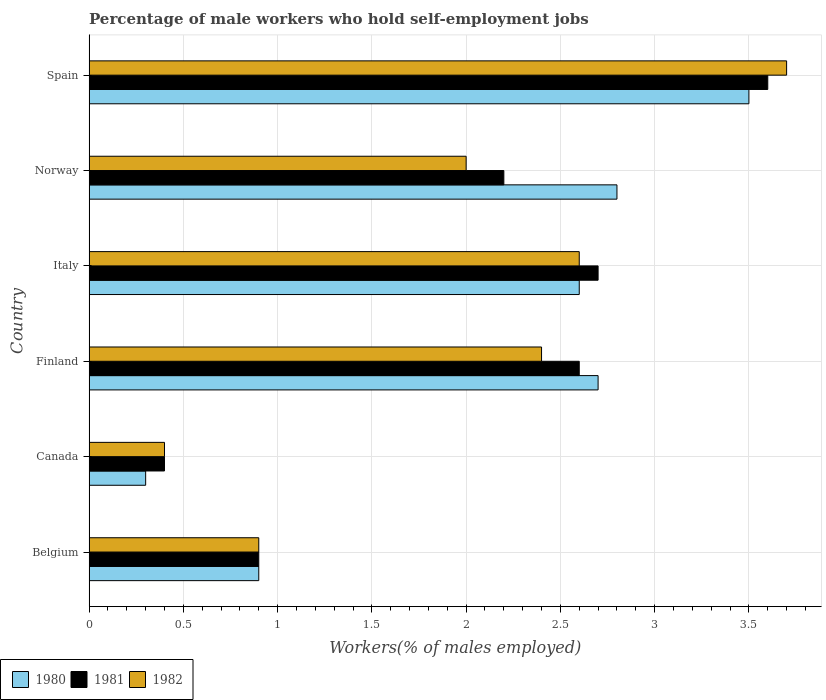How many groups of bars are there?
Offer a terse response. 6. Are the number of bars per tick equal to the number of legend labels?
Give a very brief answer. Yes. Are the number of bars on each tick of the Y-axis equal?
Ensure brevity in your answer.  Yes. How many bars are there on the 4th tick from the top?
Your answer should be compact. 3. How many bars are there on the 5th tick from the bottom?
Offer a very short reply. 3. What is the label of the 5th group of bars from the top?
Offer a very short reply. Canada. In how many cases, is the number of bars for a given country not equal to the number of legend labels?
Give a very brief answer. 0. What is the percentage of self-employed male workers in 1981 in Norway?
Your answer should be compact. 2.2. Across all countries, what is the maximum percentage of self-employed male workers in 1982?
Provide a short and direct response. 3.7. Across all countries, what is the minimum percentage of self-employed male workers in 1981?
Give a very brief answer. 0.4. What is the total percentage of self-employed male workers in 1982 in the graph?
Offer a terse response. 12. What is the difference between the percentage of self-employed male workers in 1982 in Italy and the percentage of self-employed male workers in 1980 in Norway?
Your answer should be compact. -0.2. What is the average percentage of self-employed male workers in 1980 per country?
Ensure brevity in your answer.  2.13. What is the difference between the percentage of self-employed male workers in 1980 and percentage of self-employed male workers in 1982 in Norway?
Make the answer very short. 0.8. In how many countries, is the percentage of self-employed male workers in 1982 greater than 0.30000000000000004 %?
Ensure brevity in your answer.  6. What is the ratio of the percentage of self-employed male workers in 1981 in Finland to that in Spain?
Your response must be concise. 0.72. What is the difference between the highest and the second highest percentage of self-employed male workers in 1980?
Your answer should be compact. 0.7. What is the difference between the highest and the lowest percentage of self-employed male workers in 1981?
Ensure brevity in your answer.  3.2. In how many countries, is the percentage of self-employed male workers in 1982 greater than the average percentage of self-employed male workers in 1982 taken over all countries?
Your answer should be very brief. 3. Is the sum of the percentage of self-employed male workers in 1981 in Canada and Finland greater than the maximum percentage of self-employed male workers in 1980 across all countries?
Provide a succinct answer. No. What does the 3rd bar from the top in Spain represents?
Offer a very short reply. 1980. Is it the case that in every country, the sum of the percentage of self-employed male workers in 1980 and percentage of self-employed male workers in 1982 is greater than the percentage of self-employed male workers in 1981?
Provide a short and direct response. Yes. How many bars are there?
Offer a terse response. 18. Are all the bars in the graph horizontal?
Keep it short and to the point. Yes. How many countries are there in the graph?
Give a very brief answer. 6. What is the difference between two consecutive major ticks on the X-axis?
Keep it short and to the point. 0.5. Are the values on the major ticks of X-axis written in scientific E-notation?
Provide a succinct answer. No. Does the graph contain any zero values?
Give a very brief answer. No. Does the graph contain grids?
Make the answer very short. Yes. Where does the legend appear in the graph?
Your answer should be compact. Bottom left. How many legend labels are there?
Your response must be concise. 3. How are the legend labels stacked?
Make the answer very short. Horizontal. What is the title of the graph?
Your answer should be very brief. Percentage of male workers who hold self-employment jobs. Does "1982" appear as one of the legend labels in the graph?
Offer a terse response. Yes. What is the label or title of the X-axis?
Provide a succinct answer. Workers(% of males employed). What is the label or title of the Y-axis?
Keep it short and to the point. Country. What is the Workers(% of males employed) of 1980 in Belgium?
Give a very brief answer. 0.9. What is the Workers(% of males employed) in 1981 in Belgium?
Your answer should be compact. 0.9. What is the Workers(% of males employed) of 1982 in Belgium?
Keep it short and to the point. 0.9. What is the Workers(% of males employed) of 1980 in Canada?
Ensure brevity in your answer.  0.3. What is the Workers(% of males employed) of 1981 in Canada?
Give a very brief answer. 0.4. What is the Workers(% of males employed) in 1982 in Canada?
Make the answer very short. 0.4. What is the Workers(% of males employed) of 1980 in Finland?
Provide a succinct answer. 2.7. What is the Workers(% of males employed) in 1981 in Finland?
Your response must be concise. 2.6. What is the Workers(% of males employed) in 1982 in Finland?
Make the answer very short. 2.4. What is the Workers(% of males employed) in 1980 in Italy?
Ensure brevity in your answer.  2.6. What is the Workers(% of males employed) in 1981 in Italy?
Provide a short and direct response. 2.7. What is the Workers(% of males employed) of 1982 in Italy?
Provide a succinct answer. 2.6. What is the Workers(% of males employed) in 1980 in Norway?
Your answer should be compact. 2.8. What is the Workers(% of males employed) of 1981 in Norway?
Provide a short and direct response. 2.2. What is the Workers(% of males employed) of 1981 in Spain?
Your answer should be compact. 3.6. What is the Workers(% of males employed) in 1982 in Spain?
Provide a succinct answer. 3.7. Across all countries, what is the maximum Workers(% of males employed) in 1981?
Your answer should be very brief. 3.6. Across all countries, what is the maximum Workers(% of males employed) of 1982?
Give a very brief answer. 3.7. Across all countries, what is the minimum Workers(% of males employed) in 1980?
Your answer should be compact. 0.3. Across all countries, what is the minimum Workers(% of males employed) in 1981?
Ensure brevity in your answer.  0.4. Across all countries, what is the minimum Workers(% of males employed) of 1982?
Your answer should be compact. 0.4. What is the total Workers(% of males employed) in 1982 in the graph?
Your response must be concise. 12. What is the difference between the Workers(% of males employed) in 1980 in Belgium and that in Canada?
Make the answer very short. 0.6. What is the difference between the Workers(% of males employed) of 1982 in Belgium and that in Canada?
Your answer should be very brief. 0.5. What is the difference between the Workers(% of males employed) of 1981 in Belgium and that in Finland?
Your response must be concise. -1.7. What is the difference between the Workers(% of males employed) in 1980 in Belgium and that in Italy?
Offer a terse response. -1.7. What is the difference between the Workers(% of males employed) of 1980 in Belgium and that in Norway?
Your answer should be very brief. -1.9. What is the difference between the Workers(% of males employed) of 1980 in Belgium and that in Spain?
Keep it short and to the point. -2.6. What is the difference between the Workers(% of males employed) of 1980 in Canada and that in Finland?
Keep it short and to the point. -2.4. What is the difference between the Workers(% of males employed) of 1980 in Canada and that in Italy?
Give a very brief answer. -2.3. What is the difference between the Workers(% of males employed) in 1981 in Canada and that in Italy?
Provide a succinct answer. -2.3. What is the difference between the Workers(% of males employed) in 1982 in Canada and that in Italy?
Your answer should be very brief. -2.2. What is the difference between the Workers(% of males employed) of 1980 in Canada and that in Norway?
Provide a short and direct response. -2.5. What is the difference between the Workers(% of males employed) in 1982 in Canada and that in Norway?
Your response must be concise. -1.6. What is the difference between the Workers(% of males employed) of 1980 in Canada and that in Spain?
Keep it short and to the point. -3.2. What is the difference between the Workers(% of males employed) of 1981 in Canada and that in Spain?
Provide a succinct answer. -3.2. What is the difference between the Workers(% of males employed) of 1980 in Finland and that in Italy?
Your answer should be very brief. 0.1. What is the difference between the Workers(% of males employed) in 1981 in Finland and that in Italy?
Ensure brevity in your answer.  -0.1. What is the difference between the Workers(% of males employed) in 1980 in Finland and that in Norway?
Provide a succinct answer. -0.1. What is the difference between the Workers(% of males employed) of 1981 in Finland and that in Norway?
Keep it short and to the point. 0.4. What is the difference between the Workers(% of males employed) in 1982 in Finland and that in Norway?
Provide a succinct answer. 0.4. What is the difference between the Workers(% of males employed) in 1980 in Finland and that in Spain?
Provide a short and direct response. -0.8. What is the difference between the Workers(% of males employed) of 1982 in Finland and that in Spain?
Ensure brevity in your answer.  -1.3. What is the difference between the Workers(% of males employed) of 1981 in Italy and that in Norway?
Give a very brief answer. 0.5. What is the difference between the Workers(% of males employed) in 1980 in Italy and that in Spain?
Offer a very short reply. -0.9. What is the difference between the Workers(% of males employed) of 1981 in Italy and that in Spain?
Provide a short and direct response. -0.9. What is the difference between the Workers(% of males employed) in 1982 in Italy and that in Spain?
Make the answer very short. -1.1. What is the difference between the Workers(% of males employed) of 1980 in Norway and that in Spain?
Offer a terse response. -0.7. What is the difference between the Workers(% of males employed) in 1980 in Belgium and the Workers(% of males employed) in 1982 in Italy?
Give a very brief answer. -1.7. What is the difference between the Workers(% of males employed) in 1981 in Belgium and the Workers(% of males employed) in 1982 in Italy?
Your answer should be compact. -1.7. What is the difference between the Workers(% of males employed) in 1980 in Belgium and the Workers(% of males employed) in 1982 in Norway?
Your answer should be very brief. -1.1. What is the difference between the Workers(% of males employed) of 1981 in Belgium and the Workers(% of males employed) of 1982 in Norway?
Provide a short and direct response. -1.1. What is the difference between the Workers(% of males employed) of 1980 in Belgium and the Workers(% of males employed) of 1981 in Spain?
Your answer should be very brief. -2.7. What is the difference between the Workers(% of males employed) in 1980 in Belgium and the Workers(% of males employed) in 1982 in Spain?
Keep it short and to the point. -2.8. What is the difference between the Workers(% of males employed) in 1980 in Canada and the Workers(% of males employed) in 1981 in Finland?
Keep it short and to the point. -2.3. What is the difference between the Workers(% of males employed) of 1981 in Canada and the Workers(% of males employed) of 1982 in Finland?
Your answer should be compact. -2. What is the difference between the Workers(% of males employed) in 1980 in Canada and the Workers(% of males employed) in 1982 in Italy?
Make the answer very short. -2.3. What is the difference between the Workers(% of males employed) in 1980 in Canada and the Workers(% of males employed) in 1981 in Norway?
Offer a terse response. -1.9. What is the difference between the Workers(% of males employed) in 1980 in Canada and the Workers(% of males employed) in 1982 in Norway?
Offer a terse response. -1.7. What is the difference between the Workers(% of males employed) in 1980 in Canada and the Workers(% of males employed) in 1981 in Spain?
Provide a succinct answer. -3.3. What is the difference between the Workers(% of males employed) of 1980 in Canada and the Workers(% of males employed) of 1982 in Spain?
Provide a succinct answer. -3.4. What is the difference between the Workers(% of males employed) in 1980 in Finland and the Workers(% of males employed) in 1981 in Italy?
Your response must be concise. 0. What is the difference between the Workers(% of males employed) in 1980 in Finland and the Workers(% of males employed) in 1982 in Italy?
Your answer should be compact. 0.1. What is the difference between the Workers(% of males employed) in 1981 in Finland and the Workers(% of males employed) in 1982 in Italy?
Provide a short and direct response. 0. What is the difference between the Workers(% of males employed) of 1980 in Finland and the Workers(% of males employed) of 1981 in Norway?
Make the answer very short. 0.5. What is the difference between the Workers(% of males employed) of 1981 in Finland and the Workers(% of males employed) of 1982 in Norway?
Ensure brevity in your answer.  0.6. What is the difference between the Workers(% of males employed) in 1981 in Finland and the Workers(% of males employed) in 1982 in Spain?
Ensure brevity in your answer.  -1.1. What is the difference between the Workers(% of males employed) in 1980 in Italy and the Workers(% of males employed) in 1982 in Norway?
Ensure brevity in your answer.  0.6. What is the difference between the Workers(% of males employed) in 1980 in Italy and the Workers(% of males employed) in 1981 in Spain?
Offer a very short reply. -1. What is the difference between the Workers(% of males employed) in 1981 in Italy and the Workers(% of males employed) in 1982 in Spain?
Provide a short and direct response. -1. What is the difference between the Workers(% of males employed) in 1980 in Norway and the Workers(% of males employed) in 1981 in Spain?
Ensure brevity in your answer.  -0.8. What is the difference between the Workers(% of males employed) of 1980 in Norway and the Workers(% of males employed) of 1982 in Spain?
Provide a short and direct response. -0.9. What is the difference between the Workers(% of males employed) in 1981 in Norway and the Workers(% of males employed) in 1982 in Spain?
Give a very brief answer. -1.5. What is the average Workers(% of males employed) of 1980 per country?
Make the answer very short. 2.13. What is the average Workers(% of males employed) in 1981 per country?
Keep it short and to the point. 2.07. What is the difference between the Workers(% of males employed) in 1980 and Workers(% of males employed) in 1981 in Belgium?
Your answer should be compact. 0. What is the difference between the Workers(% of males employed) of 1981 and Workers(% of males employed) of 1982 in Belgium?
Your answer should be very brief. 0. What is the difference between the Workers(% of males employed) in 1980 and Workers(% of males employed) in 1982 in Finland?
Provide a short and direct response. 0.3. What is the difference between the Workers(% of males employed) in 1981 and Workers(% of males employed) in 1982 in Finland?
Offer a very short reply. 0.2. What is the difference between the Workers(% of males employed) of 1980 and Workers(% of males employed) of 1982 in Italy?
Make the answer very short. 0. What is the difference between the Workers(% of males employed) of 1981 and Workers(% of males employed) of 1982 in Italy?
Ensure brevity in your answer.  0.1. What is the difference between the Workers(% of males employed) in 1980 and Workers(% of males employed) in 1981 in Norway?
Ensure brevity in your answer.  0.6. What is the difference between the Workers(% of males employed) of 1980 and Workers(% of males employed) of 1981 in Spain?
Your answer should be very brief. -0.1. What is the difference between the Workers(% of males employed) of 1980 and Workers(% of males employed) of 1982 in Spain?
Offer a terse response. -0.2. What is the difference between the Workers(% of males employed) of 1981 and Workers(% of males employed) of 1982 in Spain?
Give a very brief answer. -0.1. What is the ratio of the Workers(% of males employed) in 1981 in Belgium to that in Canada?
Your response must be concise. 2.25. What is the ratio of the Workers(% of males employed) in 1982 in Belgium to that in Canada?
Offer a terse response. 2.25. What is the ratio of the Workers(% of males employed) of 1980 in Belgium to that in Finland?
Provide a short and direct response. 0.33. What is the ratio of the Workers(% of males employed) in 1981 in Belgium to that in Finland?
Keep it short and to the point. 0.35. What is the ratio of the Workers(% of males employed) of 1982 in Belgium to that in Finland?
Your answer should be very brief. 0.38. What is the ratio of the Workers(% of males employed) of 1980 in Belgium to that in Italy?
Keep it short and to the point. 0.35. What is the ratio of the Workers(% of males employed) of 1982 in Belgium to that in Italy?
Give a very brief answer. 0.35. What is the ratio of the Workers(% of males employed) of 1980 in Belgium to that in Norway?
Keep it short and to the point. 0.32. What is the ratio of the Workers(% of males employed) of 1981 in Belgium to that in Norway?
Ensure brevity in your answer.  0.41. What is the ratio of the Workers(% of males employed) in 1982 in Belgium to that in Norway?
Make the answer very short. 0.45. What is the ratio of the Workers(% of males employed) of 1980 in Belgium to that in Spain?
Offer a very short reply. 0.26. What is the ratio of the Workers(% of males employed) of 1982 in Belgium to that in Spain?
Your response must be concise. 0.24. What is the ratio of the Workers(% of males employed) in 1980 in Canada to that in Finland?
Make the answer very short. 0.11. What is the ratio of the Workers(% of males employed) in 1981 in Canada to that in Finland?
Ensure brevity in your answer.  0.15. What is the ratio of the Workers(% of males employed) in 1980 in Canada to that in Italy?
Offer a terse response. 0.12. What is the ratio of the Workers(% of males employed) in 1981 in Canada to that in Italy?
Your answer should be compact. 0.15. What is the ratio of the Workers(% of males employed) of 1982 in Canada to that in Italy?
Make the answer very short. 0.15. What is the ratio of the Workers(% of males employed) of 1980 in Canada to that in Norway?
Keep it short and to the point. 0.11. What is the ratio of the Workers(% of males employed) of 1981 in Canada to that in Norway?
Your answer should be very brief. 0.18. What is the ratio of the Workers(% of males employed) of 1980 in Canada to that in Spain?
Offer a terse response. 0.09. What is the ratio of the Workers(% of males employed) of 1981 in Canada to that in Spain?
Your answer should be very brief. 0.11. What is the ratio of the Workers(% of males employed) in 1982 in Canada to that in Spain?
Your response must be concise. 0.11. What is the ratio of the Workers(% of males employed) of 1981 in Finland to that in Italy?
Make the answer very short. 0.96. What is the ratio of the Workers(% of males employed) in 1980 in Finland to that in Norway?
Your answer should be very brief. 0.96. What is the ratio of the Workers(% of males employed) in 1981 in Finland to that in Norway?
Keep it short and to the point. 1.18. What is the ratio of the Workers(% of males employed) of 1982 in Finland to that in Norway?
Your response must be concise. 1.2. What is the ratio of the Workers(% of males employed) in 1980 in Finland to that in Spain?
Keep it short and to the point. 0.77. What is the ratio of the Workers(% of males employed) of 1981 in Finland to that in Spain?
Ensure brevity in your answer.  0.72. What is the ratio of the Workers(% of males employed) in 1982 in Finland to that in Spain?
Ensure brevity in your answer.  0.65. What is the ratio of the Workers(% of males employed) in 1981 in Italy to that in Norway?
Ensure brevity in your answer.  1.23. What is the ratio of the Workers(% of males employed) in 1980 in Italy to that in Spain?
Your answer should be compact. 0.74. What is the ratio of the Workers(% of males employed) of 1982 in Italy to that in Spain?
Your answer should be very brief. 0.7. What is the ratio of the Workers(% of males employed) of 1980 in Norway to that in Spain?
Provide a succinct answer. 0.8. What is the ratio of the Workers(% of males employed) in 1981 in Norway to that in Spain?
Provide a short and direct response. 0.61. What is the ratio of the Workers(% of males employed) of 1982 in Norway to that in Spain?
Make the answer very short. 0.54. What is the difference between the highest and the second highest Workers(% of males employed) in 1981?
Give a very brief answer. 0.9. What is the difference between the highest and the second highest Workers(% of males employed) in 1982?
Ensure brevity in your answer.  1.1. 